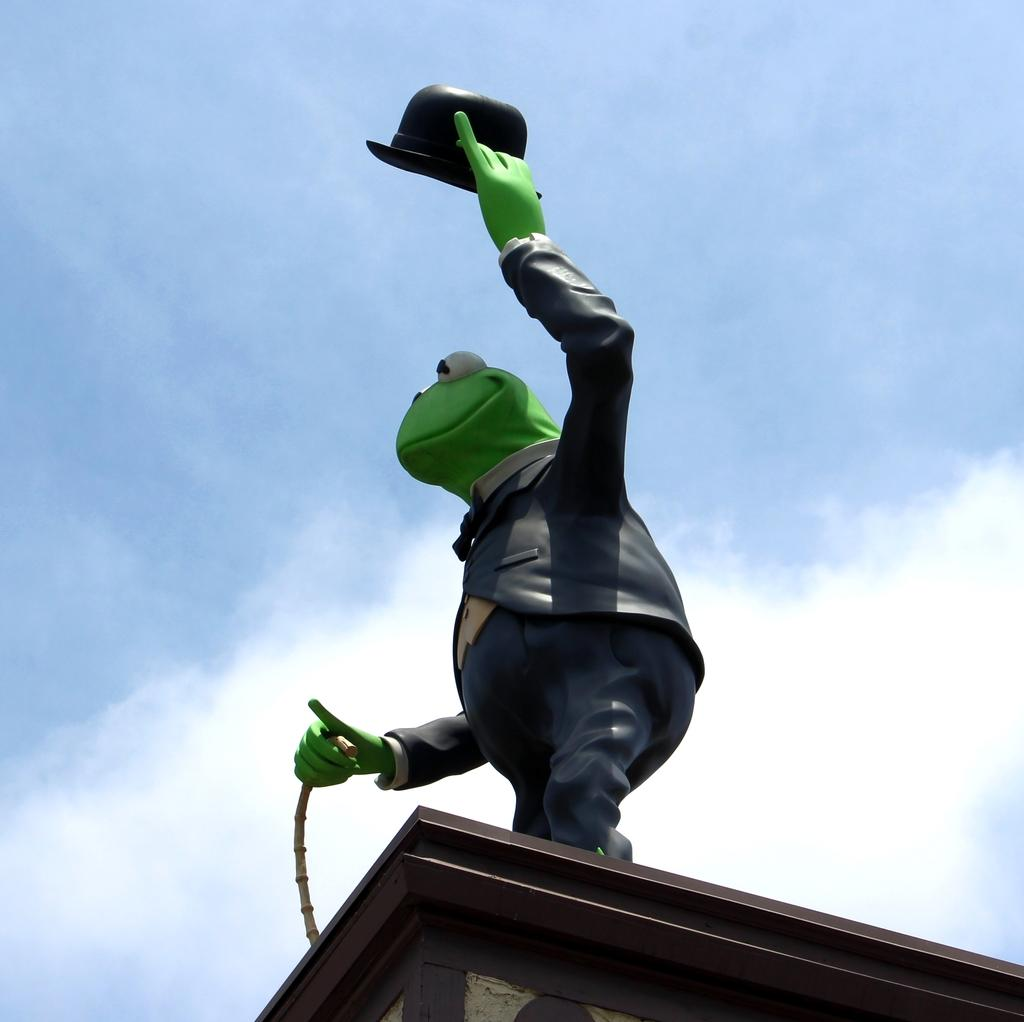What is the main subject in the center of the image? There is a statue in the center of the image. What can be seen in the background of the image? There are clouds in the sky in the background of the image. What type of pleasure can be seen enjoying the jam in the image? There is no pleasure or jam present in the image; it features a statue and clouds in the sky. What kind of jewel is adorning the statue in the image? There is no jewel present on the statue in the image. 